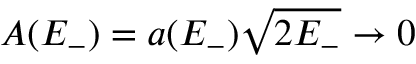<formula> <loc_0><loc_0><loc_500><loc_500>A ( E _ { - } ) = a ( E _ { - } ) \sqrt { 2 E _ { - } } \to 0</formula> 